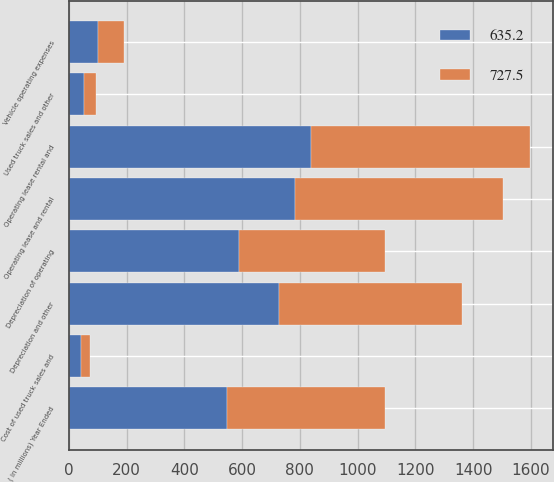Convert chart. <chart><loc_0><loc_0><loc_500><loc_500><stacked_bar_chart><ecel><fcel>( in millions) Year Ended<fcel>Operating lease and rental<fcel>Used truck sales and other<fcel>Operating lease rental and<fcel>Depreciation of operating<fcel>Vehicle operating expenses<fcel>Cost of used truck sales and<fcel>Depreciation and other<nl><fcel>635.2<fcel>548.25<fcel>784.6<fcel>53.2<fcel>837.8<fcel>587.4<fcel>99.6<fcel>40.5<fcel>727.5<nl><fcel>727.5<fcel>548.25<fcel>720.5<fcel>40<fcel>760.5<fcel>509.1<fcel>92.1<fcel>34<fcel>635.2<nl></chart> 